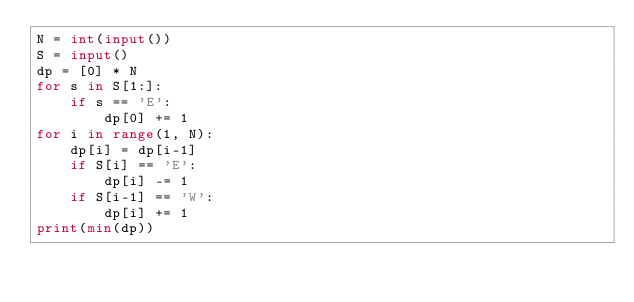<code> <loc_0><loc_0><loc_500><loc_500><_Python_>N = int(input())
S = input()
dp = [0] * N
for s in S[1:]:
    if s == 'E':
        dp[0] += 1
for i in range(1, N):
    dp[i] = dp[i-1]
    if S[i] == 'E':
        dp[i] -= 1
    if S[i-1] == 'W':
        dp[i] += 1
print(min(dp))</code> 